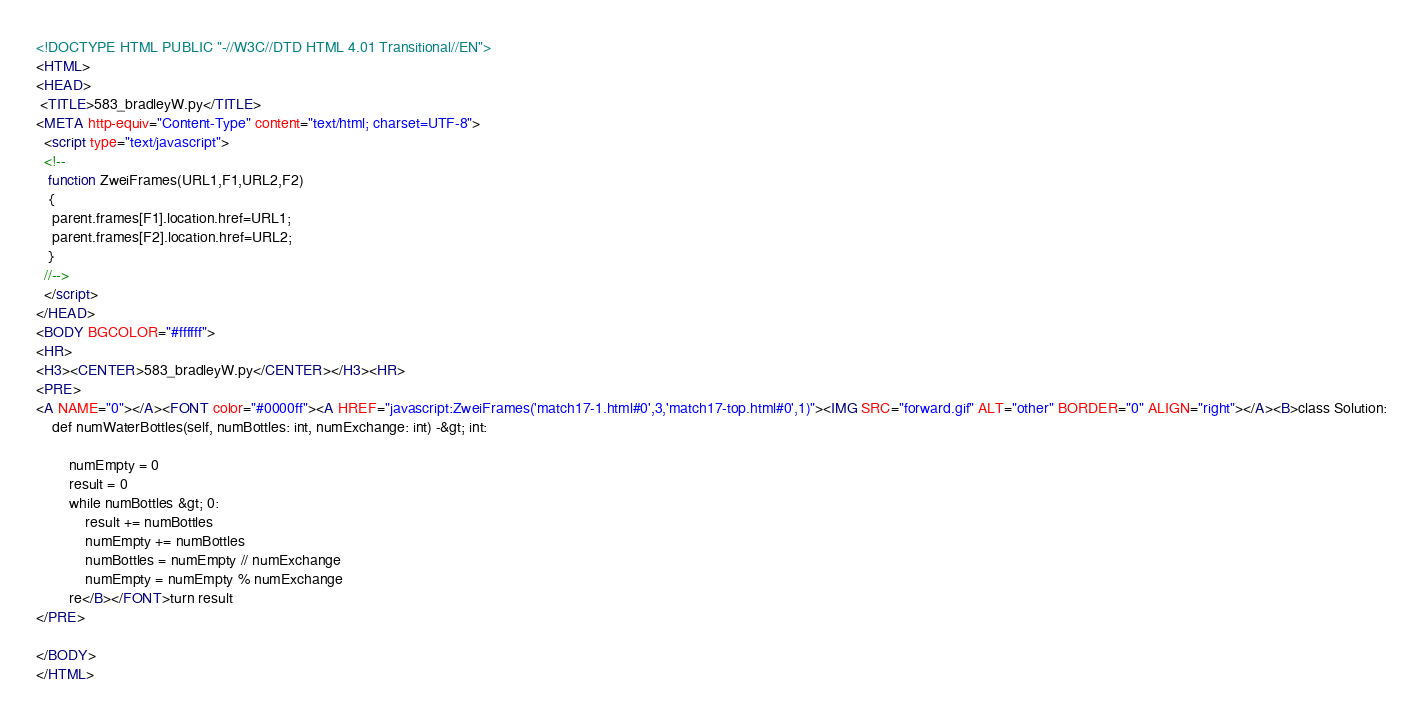Convert code to text. <code><loc_0><loc_0><loc_500><loc_500><_HTML_><!DOCTYPE HTML PUBLIC "-//W3C//DTD HTML 4.01 Transitional//EN">
<HTML>
<HEAD>
 <TITLE>583_bradleyW.py</TITLE>
<META http-equiv="Content-Type" content="text/html; charset=UTF-8">
  <script type="text/javascript">
  <!--
   function ZweiFrames(URL1,F1,URL2,F2)
   {
    parent.frames[F1].location.href=URL1;
    parent.frames[F2].location.href=URL2;
   }
  //-->
  </script>
</HEAD>
<BODY BGCOLOR="#ffffff">
<HR>
<H3><CENTER>583_bradleyW.py</CENTER></H3><HR>
<PRE>
<A NAME="0"></A><FONT color="#0000ff"><A HREF="javascript:ZweiFrames('match17-1.html#0',3,'match17-top.html#0',1)"><IMG SRC="forward.gif" ALT="other" BORDER="0" ALIGN="right"></A><B>class Solution:
    def numWaterBottles(self, numBottles: int, numExchange: int) -&gt; int:
        
        numEmpty = 0
        result = 0
        while numBottles &gt; 0:
            result += numBottles
            numEmpty += numBottles
            numBottles = numEmpty // numExchange
            numEmpty = numEmpty % numExchange
        re</B></FONT>turn result
</PRE>

</BODY>
</HTML>
</code> 